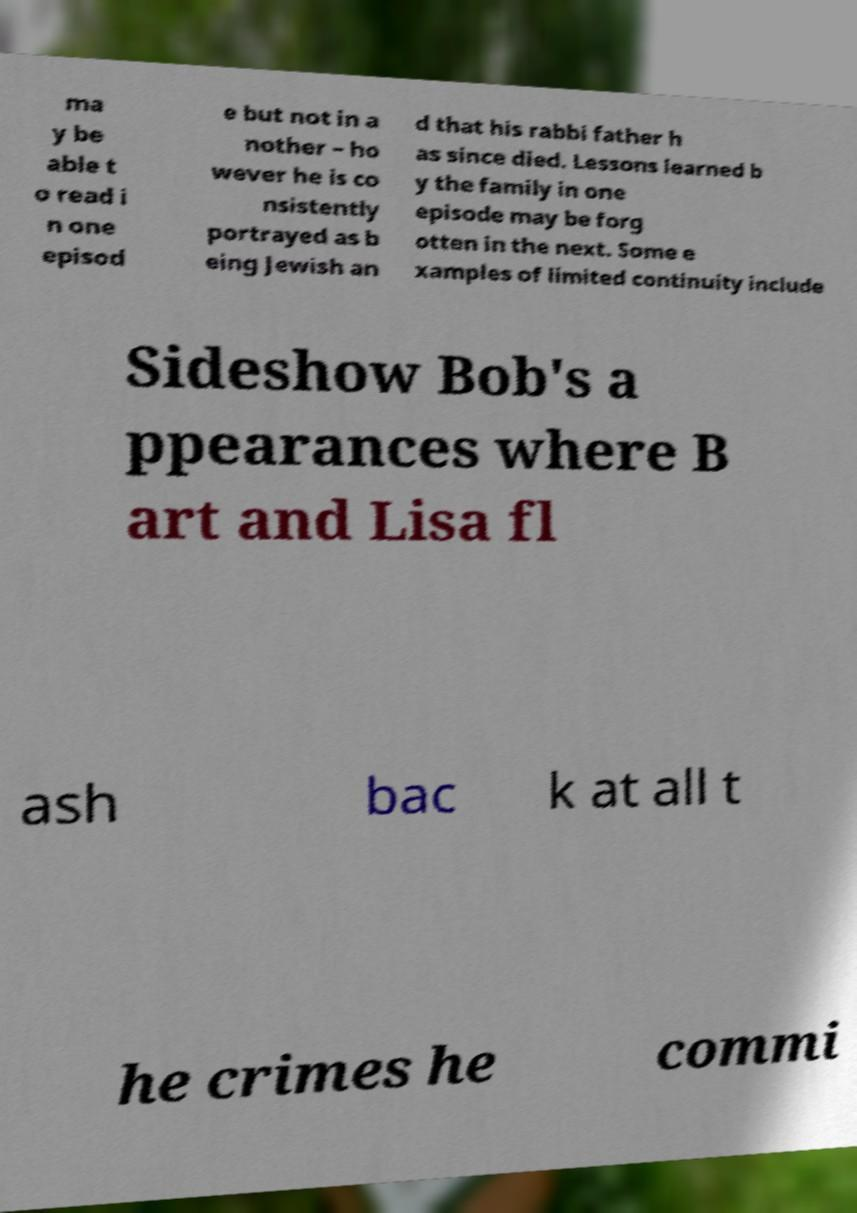Could you assist in decoding the text presented in this image and type it out clearly? ma y be able t o read i n one episod e but not in a nother – ho wever he is co nsistently portrayed as b eing Jewish an d that his rabbi father h as since died. Lessons learned b y the family in one episode may be forg otten in the next. Some e xamples of limited continuity include Sideshow Bob's a ppearances where B art and Lisa fl ash bac k at all t he crimes he commi 